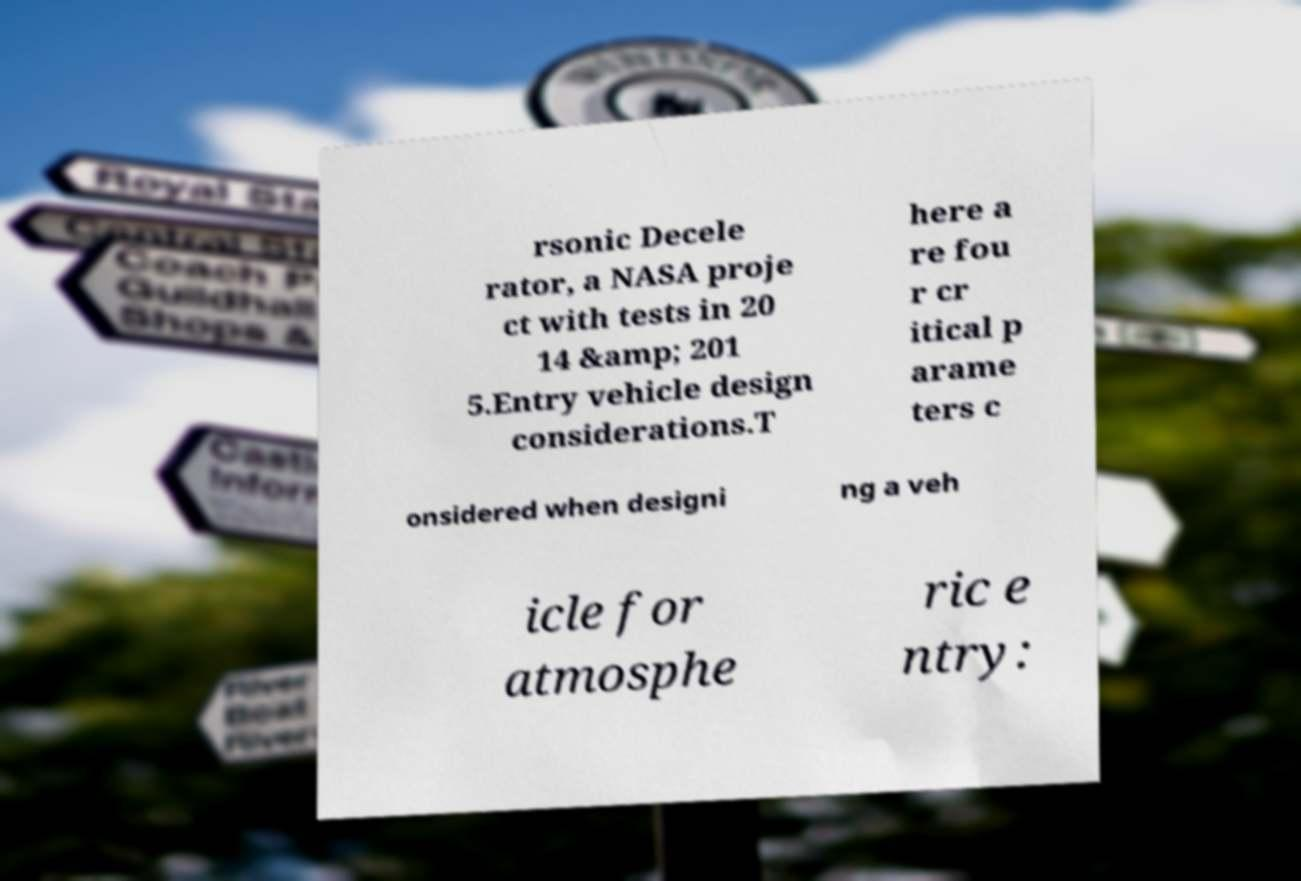Please identify and transcribe the text found in this image. rsonic Decele rator, a NASA proje ct with tests in 20 14 &amp; 201 5.Entry vehicle design considerations.T here a re fou r cr itical p arame ters c onsidered when designi ng a veh icle for atmosphe ric e ntry: 